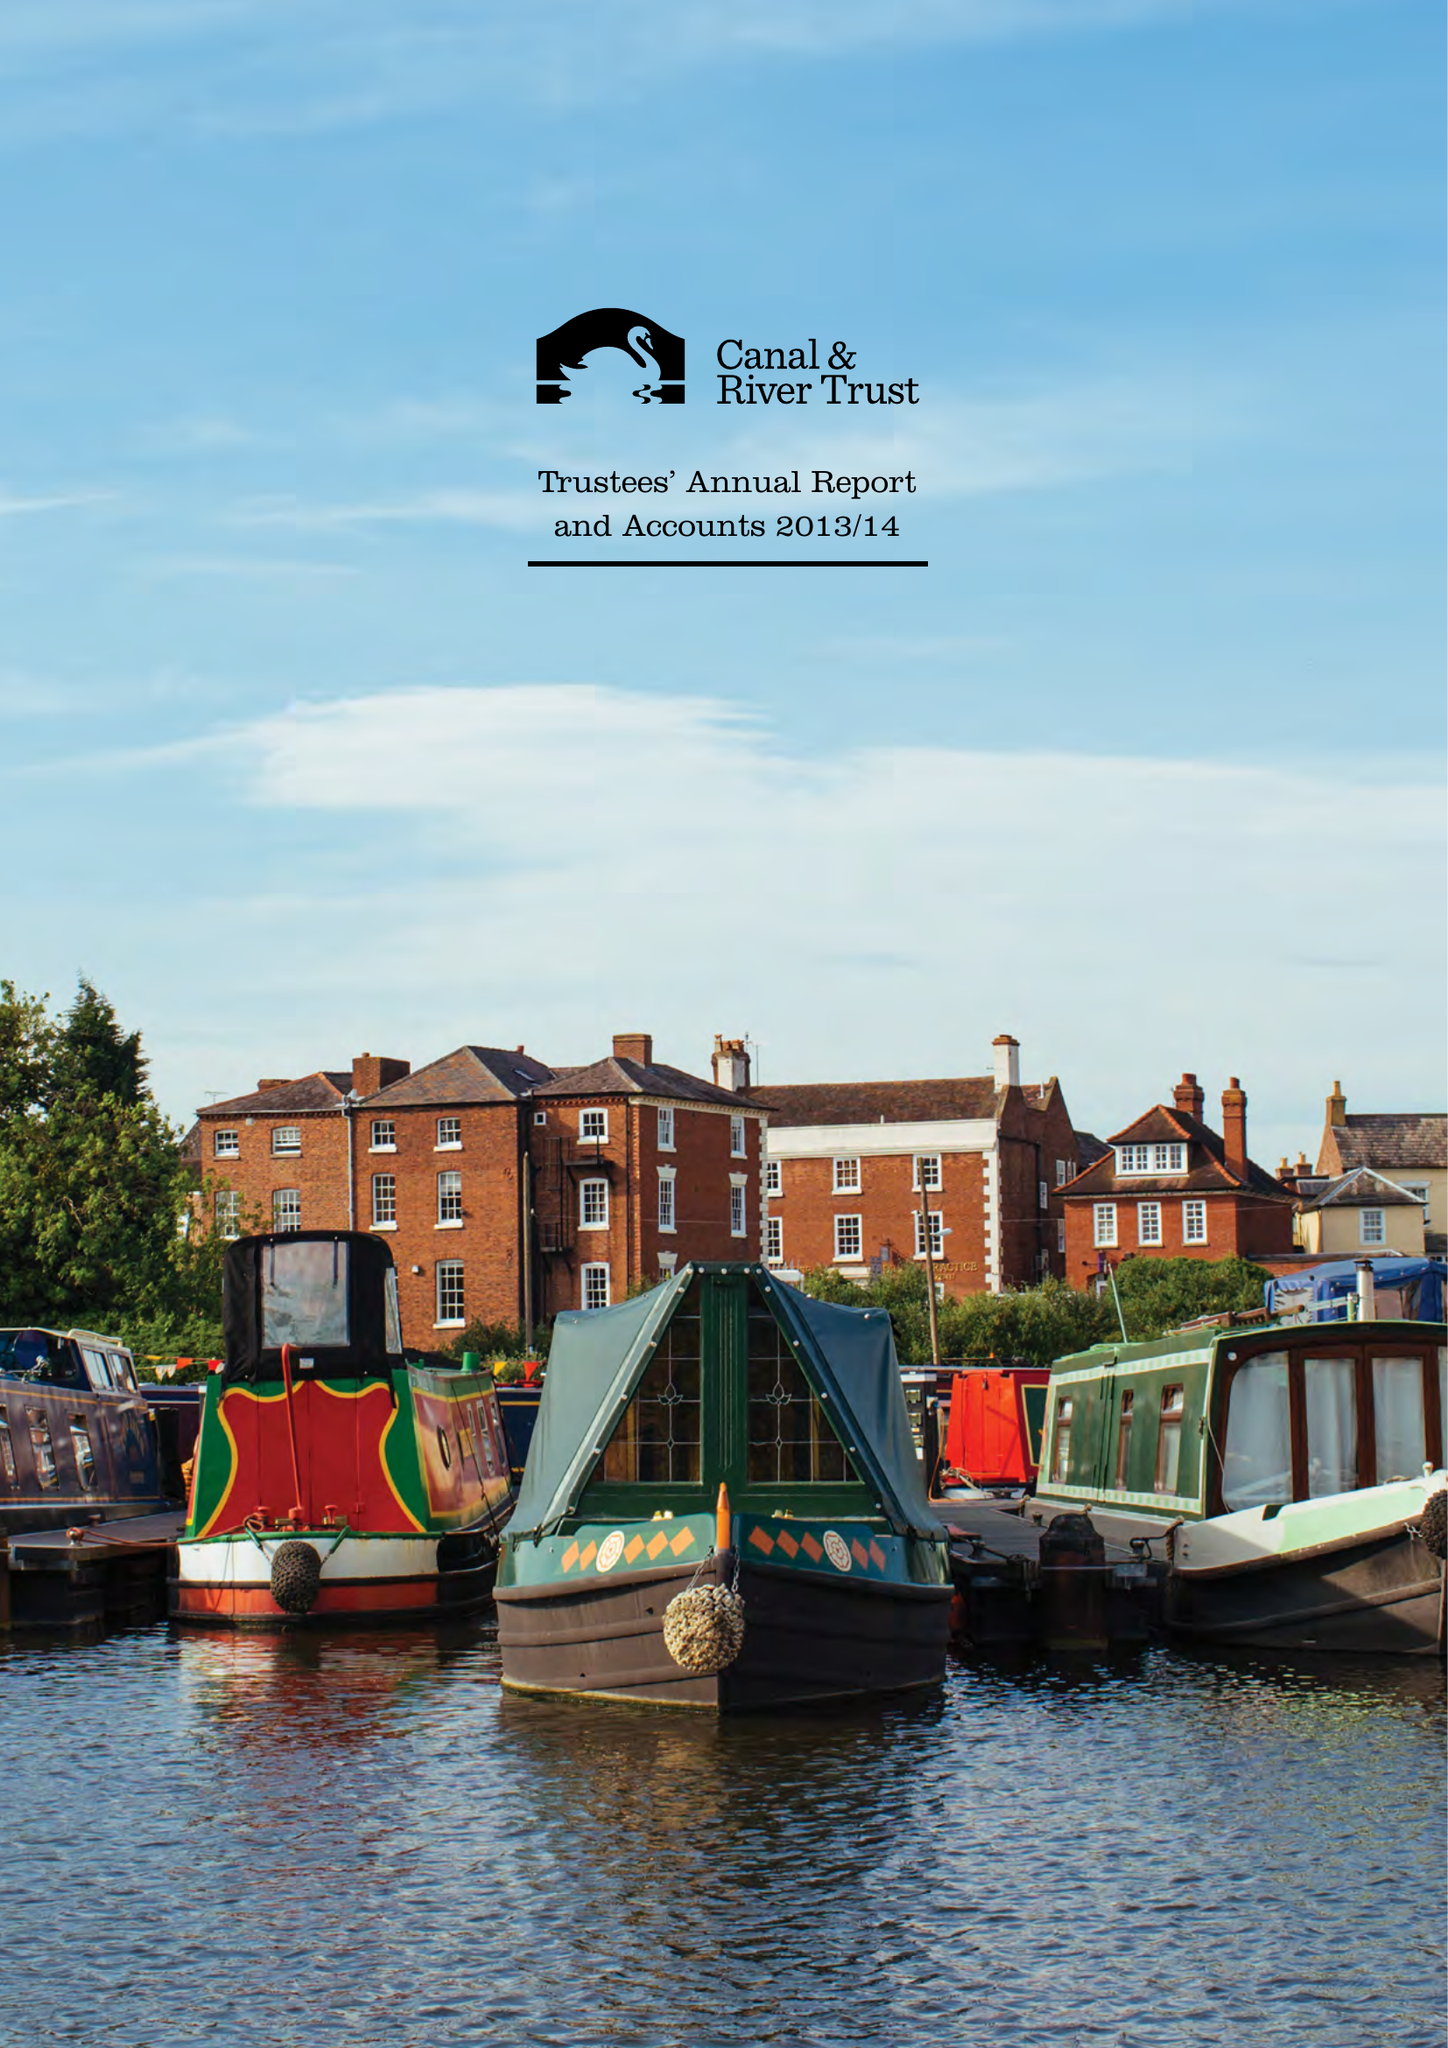What is the value for the address__post_town?
Answer the question using a single word or phrase. MILTON KEYNES 